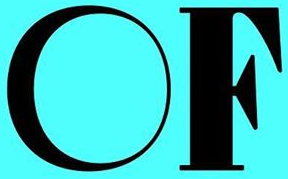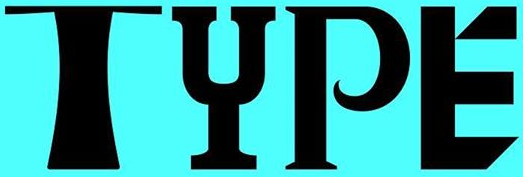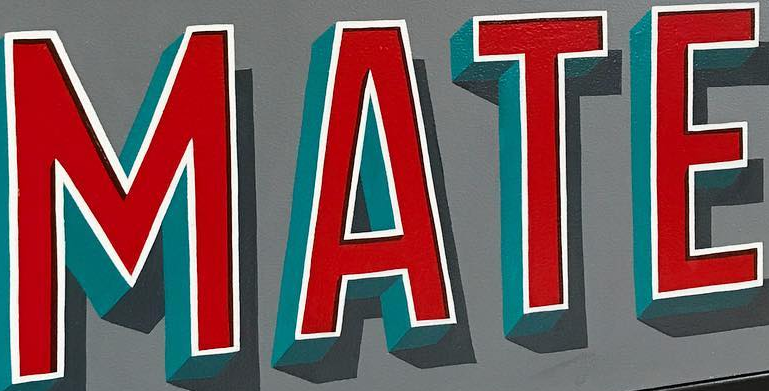Transcribe the words shown in these images in order, separated by a semicolon. OF; TYPE; MATE 